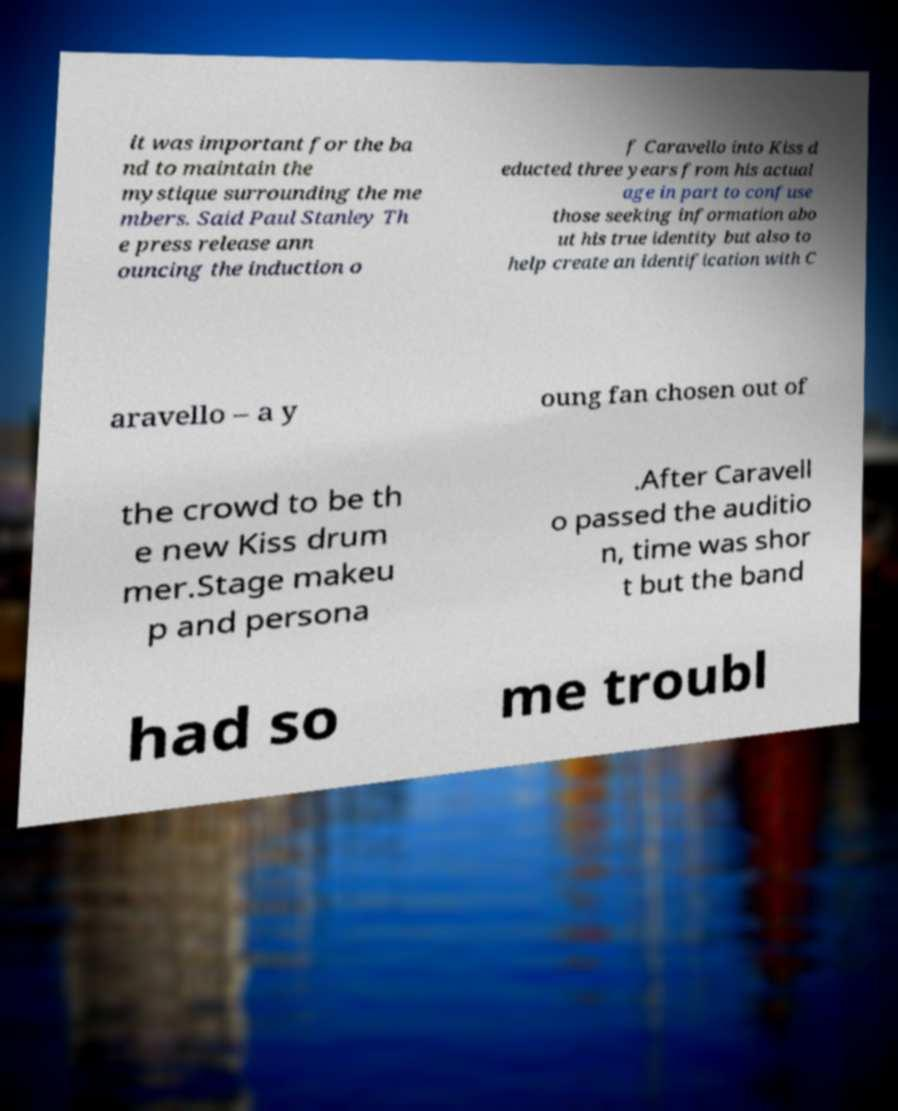What messages or text are displayed in this image? I need them in a readable, typed format. it was important for the ba nd to maintain the mystique surrounding the me mbers. Said Paul Stanley Th e press release ann ouncing the induction o f Caravello into Kiss d educted three years from his actual age in part to confuse those seeking information abo ut his true identity but also to help create an identification with C aravello – a y oung fan chosen out of the crowd to be th e new Kiss drum mer.Stage makeu p and persona .After Caravell o passed the auditio n, time was shor t but the band had so me troubl 